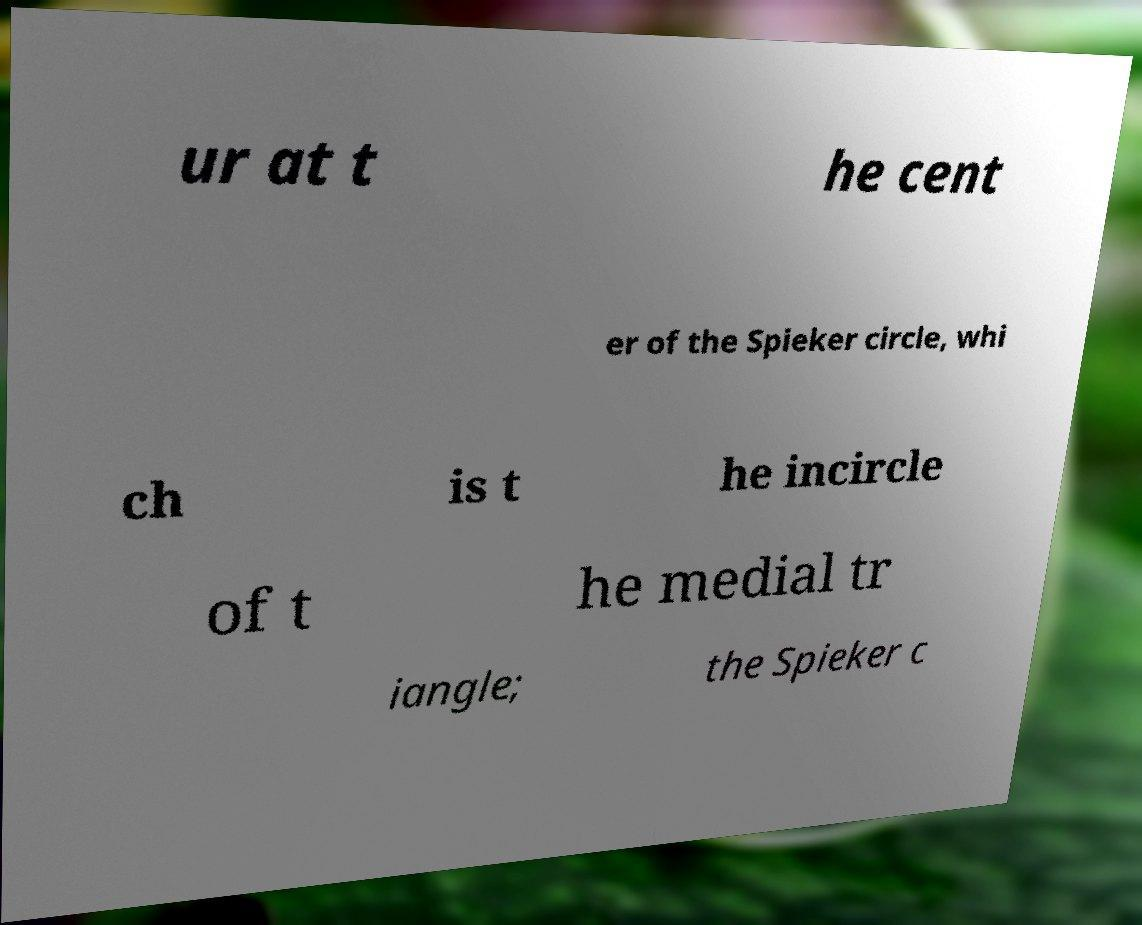Please read and relay the text visible in this image. What does it say? ur at t he cent er of the Spieker circle, whi ch is t he incircle of t he medial tr iangle; the Spieker c 